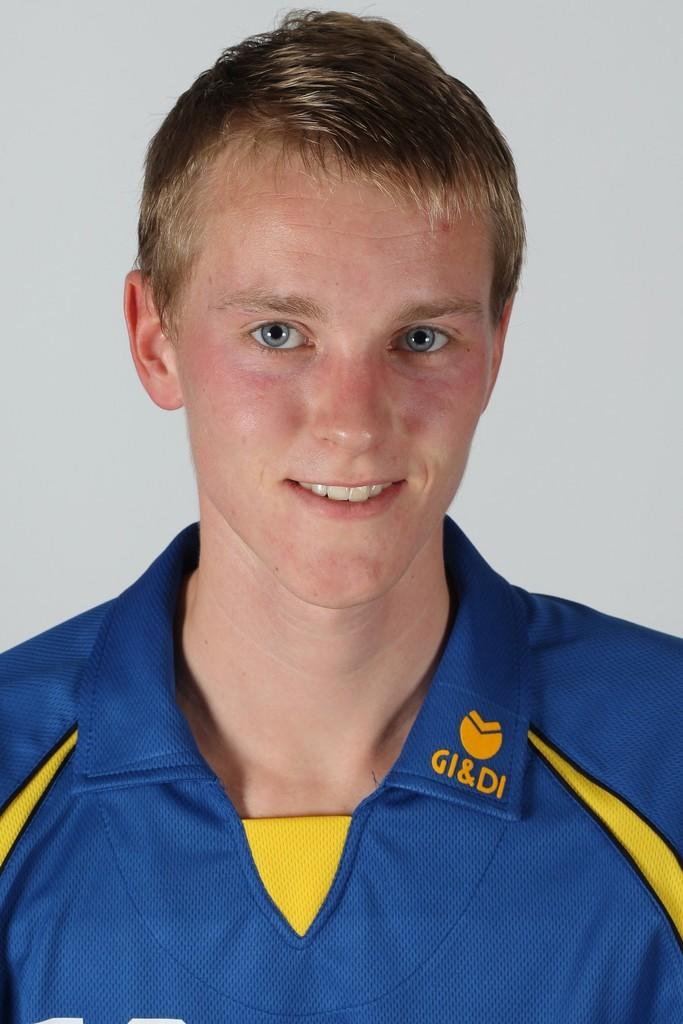<image>
Offer a succinct explanation of the picture presented. The young man pictured has the letters GI&DI embroidered on his collar. 